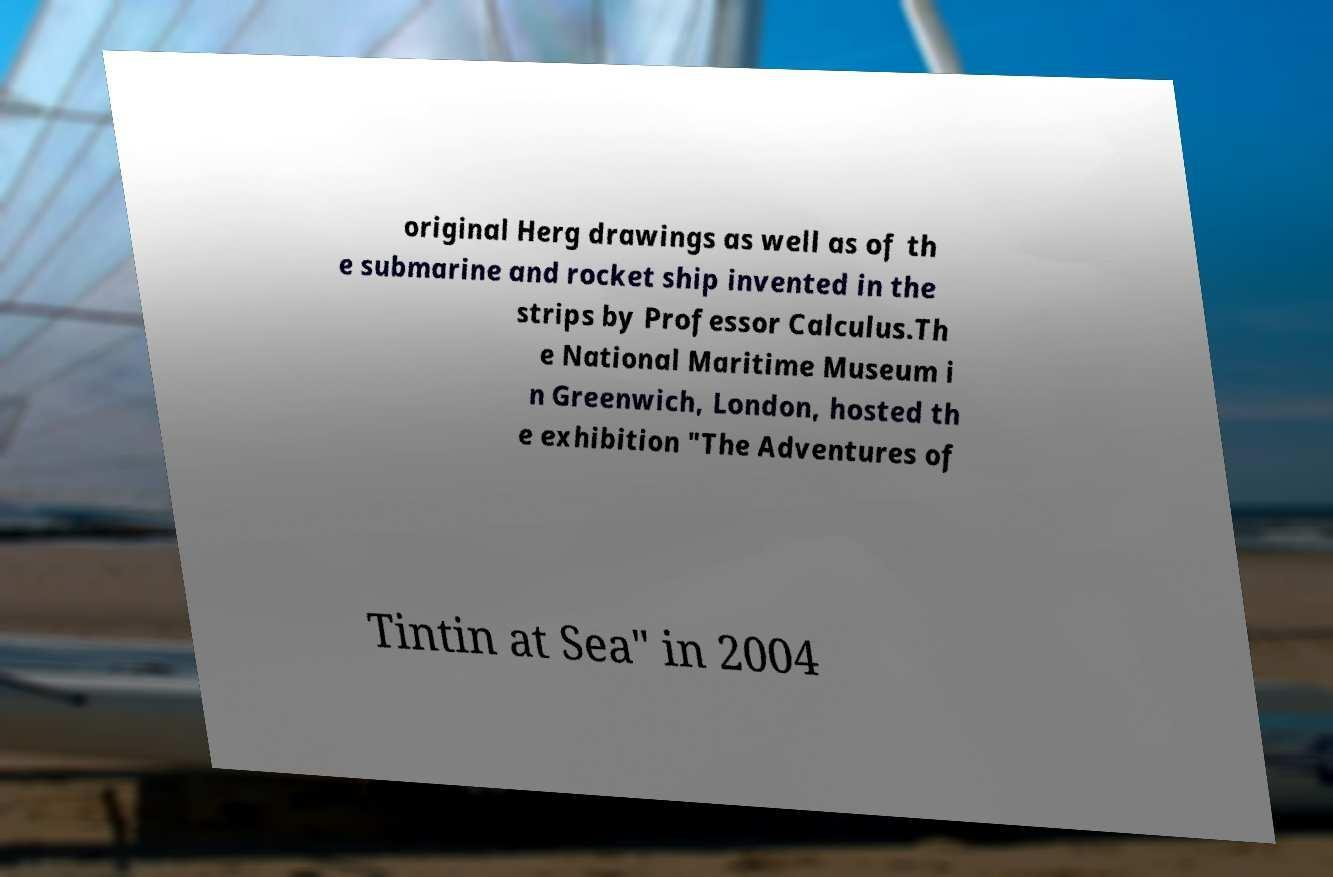Could you assist in decoding the text presented in this image and type it out clearly? original Herg drawings as well as of th e submarine and rocket ship invented in the strips by Professor Calculus.Th e National Maritime Museum i n Greenwich, London, hosted th e exhibition "The Adventures of Tintin at Sea" in 2004 